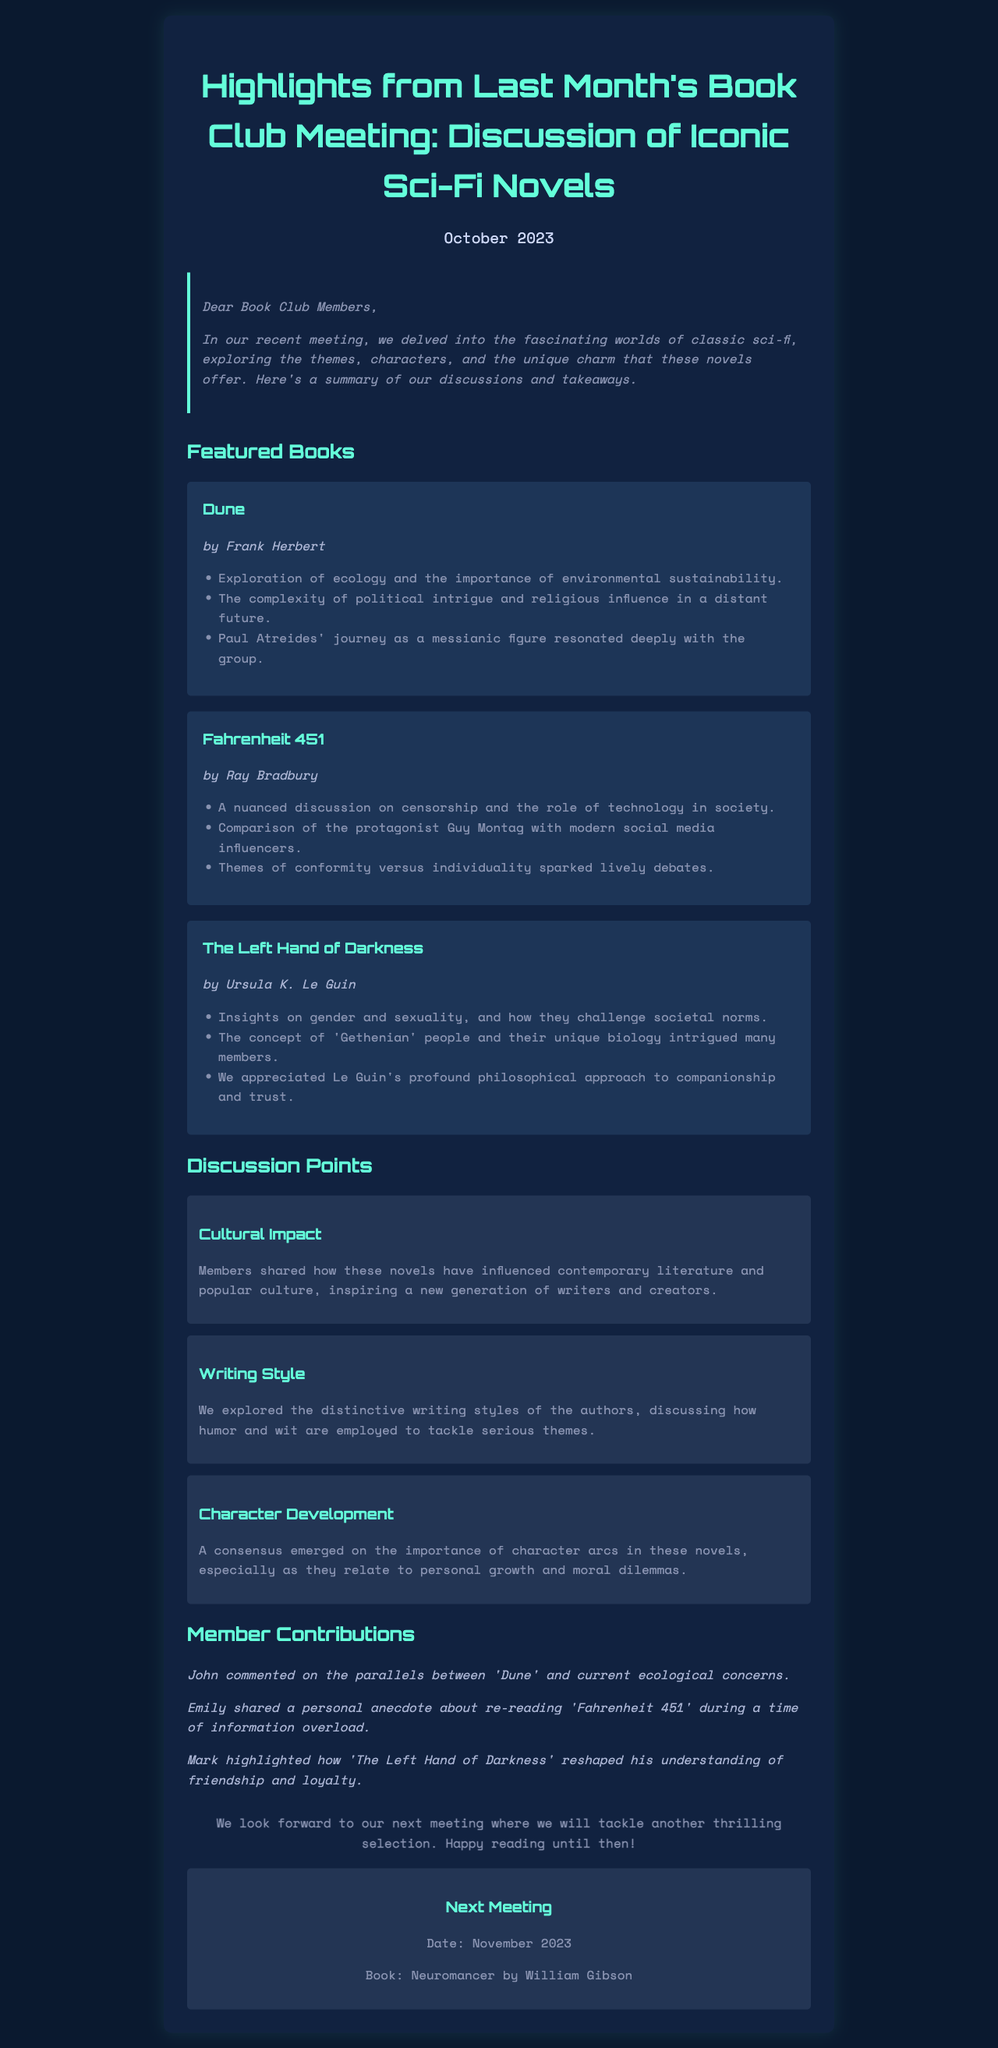what was the date of the meeting? The date of the meeting is clearly mentioned in the document.
Answer: October 2023 who is the author of Dune? The author of Dune is specified in the featured books section of the document.
Answer: Frank Herbert what are the themes discussed in Fahrenheit 451? The document lists the themes explored in Fahrenheit 451 under the featured books section.
Answer: censorship and technology which book is featured for the next meeting? Information about the next book is provided towards the end of the document.
Answer: Neuromancer what type of biological concept intrigued members in The Left Hand of Darkness? The document describes a concept that intrigued the group specifically in this book.
Answer: Gethenian how many member contributions are mentioned in the newsletter? The number of contributions listed provides insight into community engagement.
Answer: three what was a key aspect of character development discussed? The newsletter highlights a specific agreement on character development in the discussion points.
Answer: personal growth and moral dilemmas who made a comment connecting Dune to ecological concerns? The document attributes a specific contribution to one of the book club members.
Answer: John 